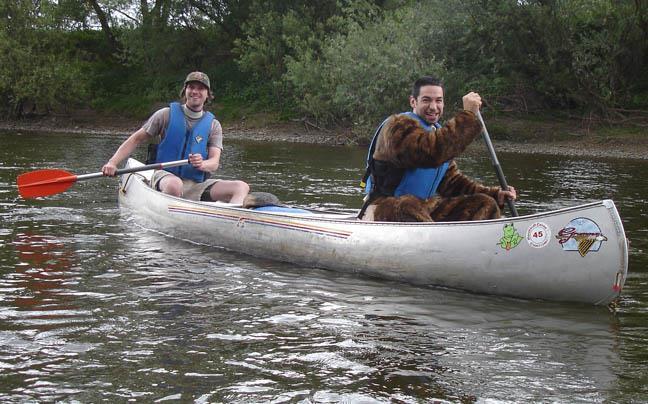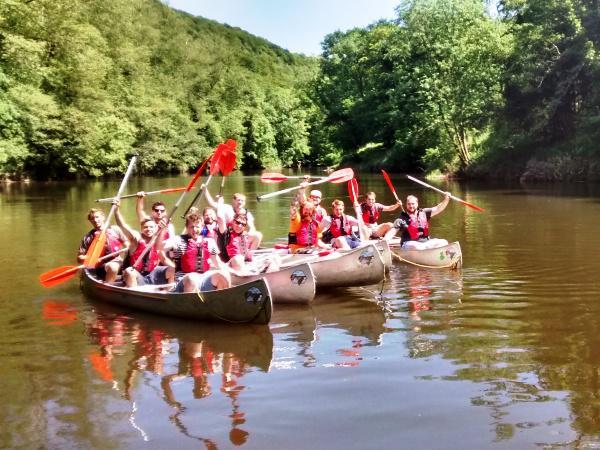The first image is the image on the left, the second image is the image on the right. Analyze the images presented: Is the assertion "One image shows only rowers in red kayaks." valid? Answer yes or no. No. 